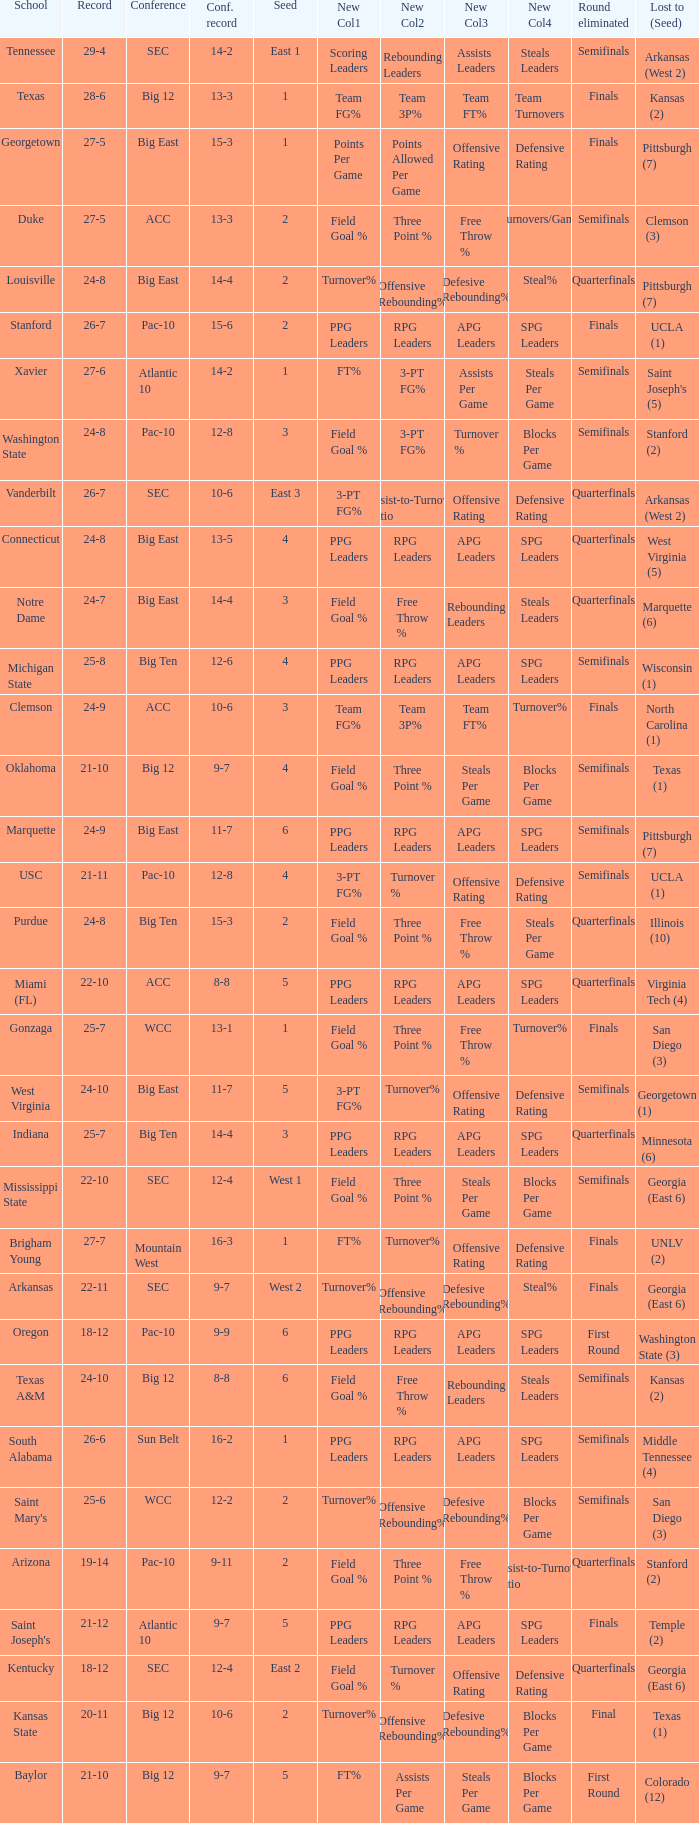Name the school where conference record is 12-6 Michigan State. 